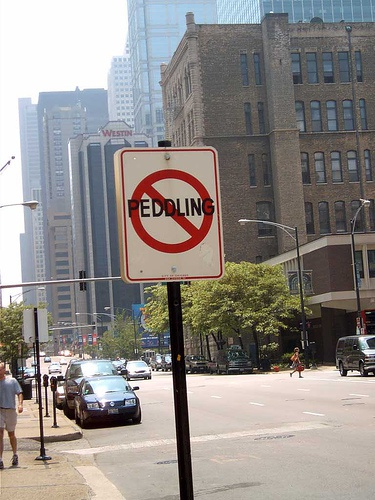Describe the objects in this image and their specific colors. I can see car in white, black, lightgray, gray, and lightblue tones, people in white, gray, and maroon tones, car in white, gray, black, and darkgray tones, truck in white, black, gray, lightgray, and darkgray tones, and truck in white, black, gray, and purple tones in this image. 